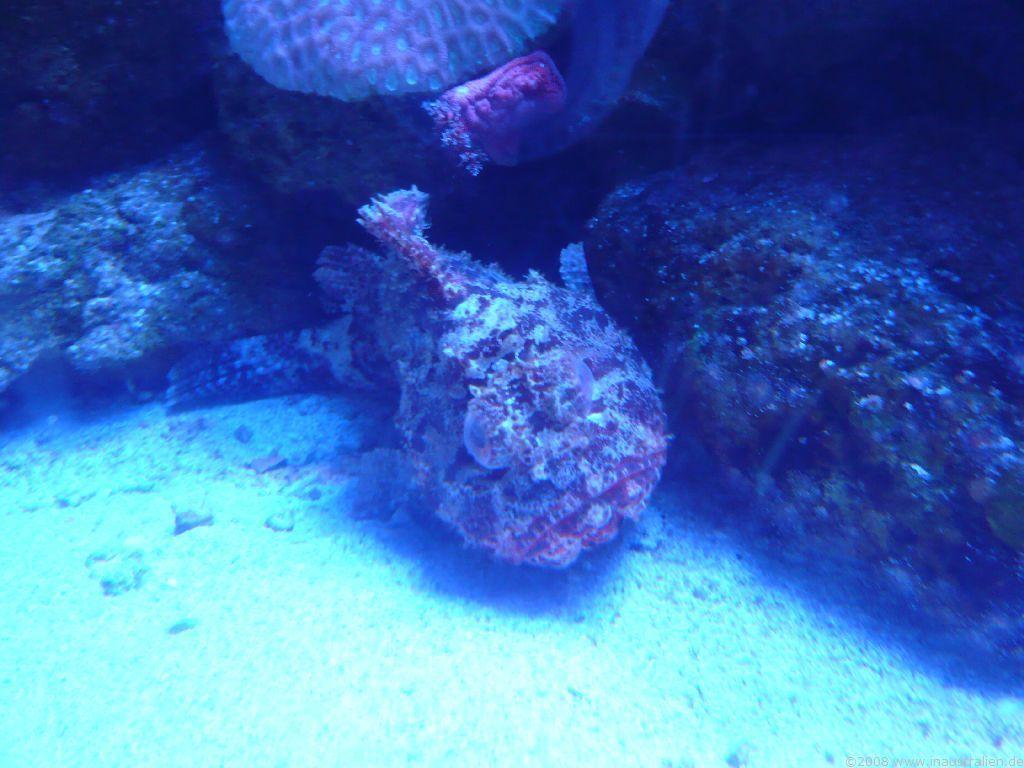How would you summarize this image in a sentence or two? In this picture, we see the aquatic animal or the aquatic plants. This picture might be clicked in the underground water. 